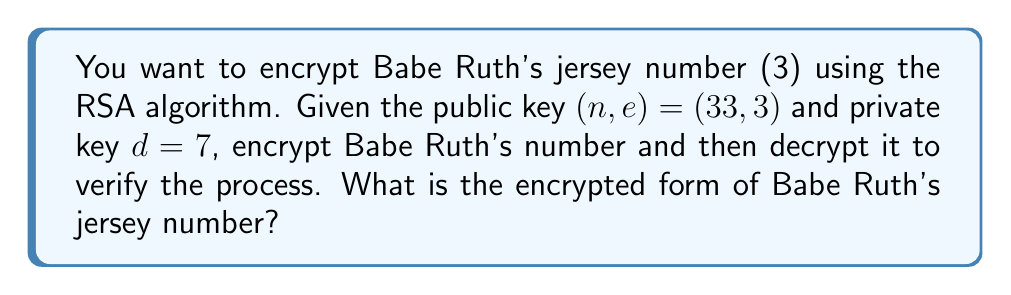Can you solve this math problem? Let's apply the RSA algorithm step-by-step:

1) Encryption:
   The formula for encryption is $c \equiv m^e \pmod{n}$
   Where $m$ is the message (Babe Ruth's jersey number), $e$ is the public exponent, and $n$ is the modulus.

   $m = 3$ (Babe Ruth's jersey number)
   $e = 3$ (given in the public key)
   $n = 33$ (given in the public key)

   $c \equiv 3^3 \pmod{33}$
   $c \equiv 27 \pmod{33}$

   So, the encrypted form of Babe Ruth's jersey number is 27.

2) Decryption (to verify):
   The formula for decryption is $m \equiv c^d \pmod{n}$
   Where $c$ is the ciphertext, $d$ is the private key, and $n$ is the modulus.

   $c = 27$ (result from encryption)
   $d = 7$ (given private key)
   $n = 33$ (given in the public key)

   $m \equiv 27^7 \pmod{33}$
   $m \equiv 3 \pmod{33}$

   This confirms that the decryption returns the original message (3), verifying the process.
Answer: 27 